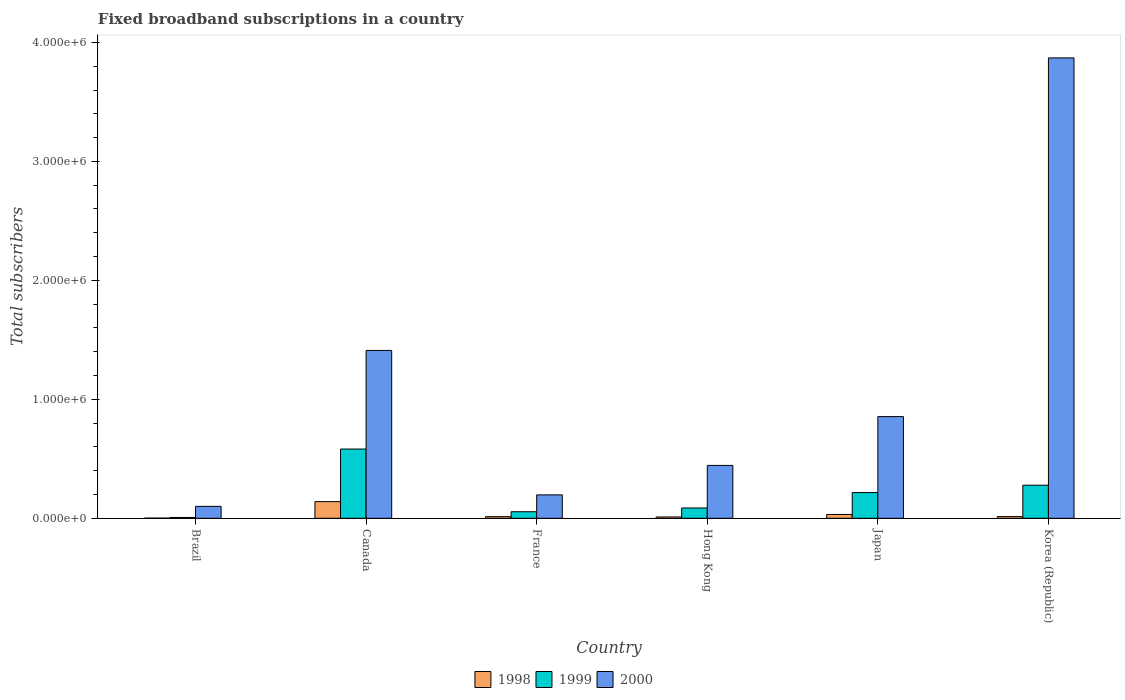How many different coloured bars are there?
Offer a terse response. 3. Are the number of bars on each tick of the X-axis equal?
Offer a very short reply. Yes. How many bars are there on the 4th tick from the right?
Offer a very short reply. 3. In how many cases, is the number of bars for a given country not equal to the number of legend labels?
Provide a succinct answer. 0. What is the number of broadband subscriptions in 2000 in Korea (Republic)?
Provide a succinct answer. 3.87e+06. Across all countries, what is the minimum number of broadband subscriptions in 2000?
Ensure brevity in your answer.  1.00e+05. In which country was the number of broadband subscriptions in 2000 maximum?
Keep it short and to the point. Korea (Republic). In which country was the number of broadband subscriptions in 1998 minimum?
Give a very brief answer. Brazil. What is the total number of broadband subscriptions in 2000 in the graph?
Make the answer very short. 6.88e+06. What is the difference between the number of broadband subscriptions in 2000 in Brazil and that in Hong Kong?
Give a very brief answer. -3.44e+05. What is the difference between the number of broadband subscriptions in 1999 in Brazil and the number of broadband subscriptions in 1998 in Canada?
Provide a short and direct response. -1.33e+05. What is the average number of broadband subscriptions in 2000 per country?
Your response must be concise. 1.15e+06. What is the difference between the number of broadband subscriptions of/in 1998 and number of broadband subscriptions of/in 2000 in Canada?
Your answer should be very brief. -1.27e+06. In how many countries, is the number of broadband subscriptions in 1999 greater than 600000?
Provide a succinct answer. 0. What is the ratio of the number of broadband subscriptions in 1999 in France to that in Hong Kong?
Keep it short and to the point. 0.64. Is the difference between the number of broadband subscriptions in 1998 in Hong Kong and Korea (Republic) greater than the difference between the number of broadband subscriptions in 2000 in Hong Kong and Korea (Republic)?
Ensure brevity in your answer.  Yes. What is the difference between the highest and the second highest number of broadband subscriptions in 2000?
Provide a short and direct response. 2.46e+06. What is the difference between the highest and the lowest number of broadband subscriptions in 1999?
Your answer should be compact. 5.75e+05. Is it the case that in every country, the sum of the number of broadband subscriptions in 2000 and number of broadband subscriptions in 1998 is greater than the number of broadband subscriptions in 1999?
Your response must be concise. Yes. Does the graph contain grids?
Provide a short and direct response. No. How are the legend labels stacked?
Keep it short and to the point. Horizontal. What is the title of the graph?
Offer a terse response. Fixed broadband subscriptions in a country. What is the label or title of the Y-axis?
Make the answer very short. Total subscribers. What is the Total subscribers of 1998 in Brazil?
Give a very brief answer. 1000. What is the Total subscribers in 1999 in Brazil?
Keep it short and to the point. 7000. What is the Total subscribers of 2000 in Brazil?
Your answer should be compact. 1.00e+05. What is the Total subscribers of 1998 in Canada?
Your answer should be very brief. 1.40e+05. What is the Total subscribers of 1999 in Canada?
Make the answer very short. 5.82e+05. What is the Total subscribers of 2000 in Canada?
Keep it short and to the point. 1.41e+06. What is the Total subscribers of 1998 in France?
Ensure brevity in your answer.  1.35e+04. What is the Total subscribers in 1999 in France?
Your answer should be very brief. 5.50e+04. What is the Total subscribers in 2000 in France?
Provide a short and direct response. 1.97e+05. What is the Total subscribers of 1998 in Hong Kong?
Provide a short and direct response. 1.10e+04. What is the Total subscribers of 1999 in Hong Kong?
Provide a succinct answer. 8.65e+04. What is the Total subscribers of 2000 in Hong Kong?
Offer a very short reply. 4.44e+05. What is the Total subscribers of 1998 in Japan?
Make the answer very short. 3.20e+04. What is the Total subscribers of 1999 in Japan?
Your answer should be compact. 2.16e+05. What is the Total subscribers of 2000 in Japan?
Your response must be concise. 8.55e+05. What is the Total subscribers of 1998 in Korea (Republic)?
Offer a terse response. 1.40e+04. What is the Total subscribers of 1999 in Korea (Republic)?
Your response must be concise. 2.78e+05. What is the Total subscribers in 2000 in Korea (Republic)?
Provide a short and direct response. 3.87e+06. Across all countries, what is the maximum Total subscribers in 1999?
Ensure brevity in your answer.  5.82e+05. Across all countries, what is the maximum Total subscribers of 2000?
Your answer should be compact. 3.87e+06. Across all countries, what is the minimum Total subscribers in 1999?
Provide a short and direct response. 7000. What is the total Total subscribers in 1998 in the graph?
Ensure brevity in your answer.  2.11e+05. What is the total Total subscribers of 1999 in the graph?
Your answer should be very brief. 1.22e+06. What is the total Total subscribers of 2000 in the graph?
Your response must be concise. 6.88e+06. What is the difference between the Total subscribers in 1998 in Brazil and that in Canada?
Provide a short and direct response. -1.39e+05. What is the difference between the Total subscribers in 1999 in Brazil and that in Canada?
Provide a short and direct response. -5.75e+05. What is the difference between the Total subscribers of 2000 in Brazil and that in Canada?
Your answer should be compact. -1.31e+06. What is the difference between the Total subscribers of 1998 in Brazil and that in France?
Your answer should be very brief. -1.25e+04. What is the difference between the Total subscribers of 1999 in Brazil and that in France?
Your answer should be compact. -4.80e+04. What is the difference between the Total subscribers of 2000 in Brazil and that in France?
Provide a succinct answer. -9.66e+04. What is the difference between the Total subscribers of 1999 in Brazil and that in Hong Kong?
Your answer should be very brief. -7.95e+04. What is the difference between the Total subscribers of 2000 in Brazil and that in Hong Kong?
Your response must be concise. -3.44e+05. What is the difference between the Total subscribers in 1998 in Brazil and that in Japan?
Give a very brief answer. -3.10e+04. What is the difference between the Total subscribers of 1999 in Brazil and that in Japan?
Offer a very short reply. -2.09e+05. What is the difference between the Total subscribers of 2000 in Brazil and that in Japan?
Keep it short and to the point. -7.55e+05. What is the difference between the Total subscribers in 1998 in Brazil and that in Korea (Republic)?
Provide a succinct answer. -1.30e+04. What is the difference between the Total subscribers of 1999 in Brazil and that in Korea (Republic)?
Offer a very short reply. -2.71e+05. What is the difference between the Total subscribers in 2000 in Brazil and that in Korea (Republic)?
Provide a succinct answer. -3.77e+06. What is the difference between the Total subscribers of 1998 in Canada and that in France?
Provide a short and direct response. 1.27e+05. What is the difference between the Total subscribers in 1999 in Canada and that in France?
Your answer should be very brief. 5.27e+05. What is the difference between the Total subscribers of 2000 in Canada and that in France?
Your answer should be compact. 1.21e+06. What is the difference between the Total subscribers in 1998 in Canada and that in Hong Kong?
Keep it short and to the point. 1.29e+05. What is the difference between the Total subscribers in 1999 in Canada and that in Hong Kong?
Provide a succinct answer. 4.96e+05. What is the difference between the Total subscribers in 2000 in Canada and that in Hong Kong?
Offer a very short reply. 9.66e+05. What is the difference between the Total subscribers of 1998 in Canada and that in Japan?
Keep it short and to the point. 1.08e+05. What is the difference between the Total subscribers of 1999 in Canada and that in Japan?
Provide a short and direct response. 3.66e+05. What is the difference between the Total subscribers in 2000 in Canada and that in Japan?
Make the answer very short. 5.56e+05. What is the difference between the Total subscribers in 1998 in Canada and that in Korea (Republic)?
Your answer should be very brief. 1.26e+05. What is the difference between the Total subscribers of 1999 in Canada and that in Korea (Republic)?
Offer a very short reply. 3.04e+05. What is the difference between the Total subscribers in 2000 in Canada and that in Korea (Republic)?
Your answer should be compact. -2.46e+06. What is the difference between the Total subscribers in 1998 in France and that in Hong Kong?
Offer a very short reply. 2464. What is the difference between the Total subscribers in 1999 in France and that in Hong Kong?
Keep it short and to the point. -3.15e+04. What is the difference between the Total subscribers in 2000 in France and that in Hong Kong?
Provide a succinct answer. -2.48e+05. What is the difference between the Total subscribers of 1998 in France and that in Japan?
Your answer should be very brief. -1.85e+04. What is the difference between the Total subscribers in 1999 in France and that in Japan?
Offer a very short reply. -1.61e+05. What is the difference between the Total subscribers in 2000 in France and that in Japan?
Give a very brief answer. -6.58e+05. What is the difference between the Total subscribers of 1998 in France and that in Korea (Republic)?
Your answer should be very brief. -536. What is the difference between the Total subscribers in 1999 in France and that in Korea (Republic)?
Provide a short and direct response. -2.23e+05. What is the difference between the Total subscribers of 2000 in France and that in Korea (Republic)?
Offer a very short reply. -3.67e+06. What is the difference between the Total subscribers in 1998 in Hong Kong and that in Japan?
Keep it short and to the point. -2.10e+04. What is the difference between the Total subscribers in 1999 in Hong Kong and that in Japan?
Keep it short and to the point. -1.30e+05. What is the difference between the Total subscribers of 2000 in Hong Kong and that in Japan?
Your answer should be compact. -4.10e+05. What is the difference between the Total subscribers of 1998 in Hong Kong and that in Korea (Republic)?
Your response must be concise. -3000. What is the difference between the Total subscribers in 1999 in Hong Kong and that in Korea (Republic)?
Make the answer very short. -1.92e+05. What is the difference between the Total subscribers in 2000 in Hong Kong and that in Korea (Republic)?
Offer a very short reply. -3.43e+06. What is the difference between the Total subscribers in 1998 in Japan and that in Korea (Republic)?
Ensure brevity in your answer.  1.80e+04. What is the difference between the Total subscribers in 1999 in Japan and that in Korea (Republic)?
Offer a terse response. -6.20e+04. What is the difference between the Total subscribers of 2000 in Japan and that in Korea (Republic)?
Your answer should be very brief. -3.02e+06. What is the difference between the Total subscribers of 1998 in Brazil and the Total subscribers of 1999 in Canada?
Make the answer very short. -5.81e+05. What is the difference between the Total subscribers in 1998 in Brazil and the Total subscribers in 2000 in Canada?
Your response must be concise. -1.41e+06. What is the difference between the Total subscribers of 1999 in Brazil and the Total subscribers of 2000 in Canada?
Provide a short and direct response. -1.40e+06. What is the difference between the Total subscribers in 1998 in Brazil and the Total subscribers in 1999 in France?
Make the answer very short. -5.40e+04. What is the difference between the Total subscribers in 1998 in Brazil and the Total subscribers in 2000 in France?
Keep it short and to the point. -1.96e+05. What is the difference between the Total subscribers in 1999 in Brazil and the Total subscribers in 2000 in France?
Keep it short and to the point. -1.90e+05. What is the difference between the Total subscribers of 1998 in Brazil and the Total subscribers of 1999 in Hong Kong?
Ensure brevity in your answer.  -8.55e+04. What is the difference between the Total subscribers of 1998 in Brazil and the Total subscribers of 2000 in Hong Kong?
Make the answer very short. -4.43e+05. What is the difference between the Total subscribers in 1999 in Brazil and the Total subscribers in 2000 in Hong Kong?
Your answer should be compact. -4.37e+05. What is the difference between the Total subscribers in 1998 in Brazil and the Total subscribers in 1999 in Japan?
Give a very brief answer. -2.15e+05. What is the difference between the Total subscribers in 1998 in Brazil and the Total subscribers in 2000 in Japan?
Give a very brief answer. -8.54e+05. What is the difference between the Total subscribers of 1999 in Brazil and the Total subscribers of 2000 in Japan?
Offer a terse response. -8.48e+05. What is the difference between the Total subscribers in 1998 in Brazil and the Total subscribers in 1999 in Korea (Republic)?
Your answer should be very brief. -2.77e+05. What is the difference between the Total subscribers of 1998 in Brazil and the Total subscribers of 2000 in Korea (Republic)?
Your answer should be very brief. -3.87e+06. What is the difference between the Total subscribers in 1999 in Brazil and the Total subscribers in 2000 in Korea (Republic)?
Provide a short and direct response. -3.86e+06. What is the difference between the Total subscribers of 1998 in Canada and the Total subscribers of 1999 in France?
Offer a terse response. 8.50e+04. What is the difference between the Total subscribers in 1998 in Canada and the Total subscribers in 2000 in France?
Your answer should be compact. -5.66e+04. What is the difference between the Total subscribers of 1999 in Canada and the Total subscribers of 2000 in France?
Provide a short and direct response. 3.85e+05. What is the difference between the Total subscribers in 1998 in Canada and the Total subscribers in 1999 in Hong Kong?
Your answer should be compact. 5.35e+04. What is the difference between the Total subscribers in 1998 in Canada and the Total subscribers in 2000 in Hong Kong?
Ensure brevity in your answer.  -3.04e+05. What is the difference between the Total subscribers in 1999 in Canada and the Total subscribers in 2000 in Hong Kong?
Give a very brief answer. 1.38e+05. What is the difference between the Total subscribers of 1998 in Canada and the Total subscribers of 1999 in Japan?
Your answer should be very brief. -7.60e+04. What is the difference between the Total subscribers of 1998 in Canada and the Total subscribers of 2000 in Japan?
Your response must be concise. -7.15e+05. What is the difference between the Total subscribers of 1999 in Canada and the Total subscribers of 2000 in Japan?
Ensure brevity in your answer.  -2.73e+05. What is the difference between the Total subscribers in 1998 in Canada and the Total subscribers in 1999 in Korea (Republic)?
Make the answer very short. -1.38e+05. What is the difference between the Total subscribers of 1998 in Canada and the Total subscribers of 2000 in Korea (Republic)?
Ensure brevity in your answer.  -3.73e+06. What is the difference between the Total subscribers in 1999 in Canada and the Total subscribers in 2000 in Korea (Republic)?
Provide a short and direct response. -3.29e+06. What is the difference between the Total subscribers of 1998 in France and the Total subscribers of 1999 in Hong Kong?
Keep it short and to the point. -7.30e+04. What is the difference between the Total subscribers in 1998 in France and the Total subscribers in 2000 in Hong Kong?
Offer a terse response. -4.31e+05. What is the difference between the Total subscribers of 1999 in France and the Total subscribers of 2000 in Hong Kong?
Your answer should be compact. -3.89e+05. What is the difference between the Total subscribers of 1998 in France and the Total subscribers of 1999 in Japan?
Your response must be concise. -2.03e+05. What is the difference between the Total subscribers of 1998 in France and the Total subscribers of 2000 in Japan?
Your answer should be compact. -8.41e+05. What is the difference between the Total subscribers in 1999 in France and the Total subscribers in 2000 in Japan?
Keep it short and to the point. -8.00e+05. What is the difference between the Total subscribers in 1998 in France and the Total subscribers in 1999 in Korea (Republic)?
Provide a succinct answer. -2.65e+05. What is the difference between the Total subscribers in 1998 in France and the Total subscribers in 2000 in Korea (Republic)?
Give a very brief answer. -3.86e+06. What is the difference between the Total subscribers of 1999 in France and the Total subscribers of 2000 in Korea (Republic)?
Keep it short and to the point. -3.82e+06. What is the difference between the Total subscribers in 1998 in Hong Kong and the Total subscribers in 1999 in Japan?
Provide a short and direct response. -2.05e+05. What is the difference between the Total subscribers in 1998 in Hong Kong and the Total subscribers in 2000 in Japan?
Your response must be concise. -8.44e+05. What is the difference between the Total subscribers in 1999 in Hong Kong and the Total subscribers in 2000 in Japan?
Your answer should be compact. -7.68e+05. What is the difference between the Total subscribers of 1998 in Hong Kong and the Total subscribers of 1999 in Korea (Republic)?
Offer a terse response. -2.67e+05. What is the difference between the Total subscribers in 1998 in Hong Kong and the Total subscribers in 2000 in Korea (Republic)?
Offer a terse response. -3.86e+06. What is the difference between the Total subscribers in 1999 in Hong Kong and the Total subscribers in 2000 in Korea (Republic)?
Offer a very short reply. -3.78e+06. What is the difference between the Total subscribers of 1998 in Japan and the Total subscribers of 1999 in Korea (Republic)?
Your answer should be compact. -2.46e+05. What is the difference between the Total subscribers of 1998 in Japan and the Total subscribers of 2000 in Korea (Republic)?
Offer a very short reply. -3.84e+06. What is the difference between the Total subscribers of 1999 in Japan and the Total subscribers of 2000 in Korea (Republic)?
Make the answer very short. -3.65e+06. What is the average Total subscribers in 1998 per country?
Offer a very short reply. 3.52e+04. What is the average Total subscribers of 1999 per country?
Make the answer very short. 2.04e+05. What is the average Total subscribers of 2000 per country?
Provide a short and direct response. 1.15e+06. What is the difference between the Total subscribers of 1998 and Total subscribers of 1999 in Brazil?
Ensure brevity in your answer.  -6000. What is the difference between the Total subscribers of 1998 and Total subscribers of 2000 in Brazil?
Give a very brief answer. -9.90e+04. What is the difference between the Total subscribers in 1999 and Total subscribers in 2000 in Brazil?
Make the answer very short. -9.30e+04. What is the difference between the Total subscribers of 1998 and Total subscribers of 1999 in Canada?
Your response must be concise. -4.42e+05. What is the difference between the Total subscribers of 1998 and Total subscribers of 2000 in Canada?
Your response must be concise. -1.27e+06. What is the difference between the Total subscribers in 1999 and Total subscribers in 2000 in Canada?
Your answer should be very brief. -8.29e+05. What is the difference between the Total subscribers of 1998 and Total subscribers of 1999 in France?
Ensure brevity in your answer.  -4.15e+04. What is the difference between the Total subscribers in 1998 and Total subscribers in 2000 in France?
Your response must be concise. -1.83e+05. What is the difference between the Total subscribers in 1999 and Total subscribers in 2000 in France?
Give a very brief answer. -1.42e+05. What is the difference between the Total subscribers in 1998 and Total subscribers in 1999 in Hong Kong?
Provide a succinct answer. -7.55e+04. What is the difference between the Total subscribers of 1998 and Total subscribers of 2000 in Hong Kong?
Your answer should be very brief. -4.33e+05. What is the difference between the Total subscribers of 1999 and Total subscribers of 2000 in Hong Kong?
Provide a short and direct response. -3.58e+05. What is the difference between the Total subscribers in 1998 and Total subscribers in 1999 in Japan?
Make the answer very short. -1.84e+05. What is the difference between the Total subscribers of 1998 and Total subscribers of 2000 in Japan?
Offer a very short reply. -8.23e+05. What is the difference between the Total subscribers of 1999 and Total subscribers of 2000 in Japan?
Your answer should be compact. -6.39e+05. What is the difference between the Total subscribers in 1998 and Total subscribers in 1999 in Korea (Republic)?
Offer a terse response. -2.64e+05. What is the difference between the Total subscribers of 1998 and Total subscribers of 2000 in Korea (Republic)?
Offer a very short reply. -3.86e+06. What is the difference between the Total subscribers of 1999 and Total subscribers of 2000 in Korea (Republic)?
Provide a short and direct response. -3.59e+06. What is the ratio of the Total subscribers of 1998 in Brazil to that in Canada?
Your response must be concise. 0.01. What is the ratio of the Total subscribers of 1999 in Brazil to that in Canada?
Give a very brief answer. 0.01. What is the ratio of the Total subscribers in 2000 in Brazil to that in Canada?
Your answer should be very brief. 0.07. What is the ratio of the Total subscribers of 1998 in Brazil to that in France?
Provide a short and direct response. 0.07. What is the ratio of the Total subscribers of 1999 in Brazil to that in France?
Keep it short and to the point. 0.13. What is the ratio of the Total subscribers of 2000 in Brazil to that in France?
Provide a short and direct response. 0.51. What is the ratio of the Total subscribers in 1998 in Brazil to that in Hong Kong?
Offer a terse response. 0.09. What is the ratio of the Total subscribers in 1999 in Brazil to that in Hong Kong?
Make the answer very short. 0.08. What is the ratio of the Total subscribers in 2000 in Brazil to that in Hong Kong?
Give a very brief answer. 0.23. What is the ratio of the Total subscribers in 1998 in Brazil to that in Japan?
Give a very brief answer. 0.03. What is the ratio of the Total subscribers of 1999 in Brazil to that in Japan?
Keep it short and to the point. 0.03. What is the ratio of the Total subscribers in 2000 in Brazil to that in Japan?
Make the answer very short. 0.12. What is the ratio of the Total subscribers of 1998 in Brazil to that in Korea (Republic)?
Make the answer very short. 0.07. What is the ratio of the Total subscribers in 1999 in Brazil to that in Korea (Republic)?
Make the answer very short. 0.03. What is the ratio of the Total subscribers of 2000 in Brazil to that in Korea (Republic)?
Your answer should be compact. 0.03. What is the ratio of the Total subscribers of 1998 in Canada to that in France?
Offer a very short reply. 10.4. What is the ratio of the Total subscribers of 1999 in Canada to that in France?
Ensure brevity in your answer.  10.58. What is the ratio of the Total subscribers in 2000 in Canada to that in France?
Offer a terse response. 7.18. What is the ratio of the Total subscribers in 1998 in Canada to that in Hong Kong?
Provide a succinct answer. 12.73. What is the ratio of the Total subscribers of 1999 in Canada to that in Hong Kong?
Your answer should be compact. 6.73. What is the ratio of the Total subscribers in 2000 in Canada to that in Hong Kong?
Offer a very short reply. 3.17. What is the ratio of the Total subscribers in 1998 in Canada to that in Japan?
Provide a short and direct response. 4.38. What is the ratio of the Total subscribers in 1999 in Canada to that in Japan?
Provide a succinct answer. 2.69. What is the ratio of the Total subscribers of 2000 in Canada to that in Japan?
Your response must be concise. 1.65. What is the ratio of the Total subscribers of 1999 in Canada to that in Korea (Republic)?
Ensure brevity in your answer.  2.09. What is the ratio of the Total subscribers of 2000 in Canada to that in Korea (Republic)?
Ensure brevity in your answer.  0.36. What is the ratio of the Total subscribers of 1998 in France to that in Hong Kong?
Your answer should be compact. 1.22. What is the ratio of the Total subscribers of 1999 in France to that in Hong Kong?
Make the answer very short. 0.64. What is the ratio of the Total subscribers in 2000 in France to that in Hong Kong?
Your answer should be very brief. 0.44. What is the ratio of the Total subscribers of 1998 in France to that in Japan?
Ensure brevity in your answer.  0.42. What is the ratio of the Total subscribers in 1999 in France to that in Japan?
Keep it short and to the point. 0.25. What is the ratio of the Total subscribers of 2000 in France to that in Japan?
Give a very brief answer. 0.23. What is the ratio of the Total subscribers of 1998 in France to that in Korea (Republic)?
Your answer should be compact. 0.96. What is the ratio of the Total subscribers of 1999 in France to that in Korea (Republic)?
Ensure brevity in your answer.  0.2. What is the ratio of the Total subscribers in 2000 in France to that in Korea (Republic)?
Offer a terse response. 0.05. What is the ratio of the Total subscribers in 1998 in Hong Kong to that in Japan?
Make the answer very short. 0.34. What is the ratio of the Total subscribers of 1999 in Hong Kong to that in Japan?
Offer a terse response. 0.4. What is the ratio of the Total subscribers of 2000 in Hong Kong to that in Japan?
Provide a short and direct response. 0.52. What is the ratio of the Total subscribers in 1998 in Hong Kong to that in Korea (Republic)?
Offer a terse response. 0.79. What is the ratio of the Total subscribers of 1999 in Hong Kong to that in Korea (Republic)?
Your response must be concise. 0.31. What is the ratio of the Total subscribers of 2000 in Hong Kong to that in Korea (Republic)?
Offer a terse response. 0.11. What is the ratio of the Total subscribers of 1998 in Japan to that in Korea (Republic)?
Provide a short and direct response. 2.29. What is the ratio of the Total subscribers of 1999 in Japan to that in Korea (Republic)?
Provide a succinct answer. 0.78. What is the ratio of the Total subscribers in 2000 in Japan to that in Korea (Republic)?
Your response must be concise. 0.22. What is the difference between the highest and the second highest Total subscribers in 1998?
Your response must be concise. 1.08e+05. What is the difference between the highest and the second highest Total subscribers of 1999?
Offer a terse response. 3.04e+05. What is the difference between the highest and the second highest Total subscribers in 2000?
Offer a very short reply. 2.46e+06. What is the difference between the highest and the lowest Total subscribers of 1998?
Offer a terse response. 1.39e+05. What is the difference between the highest and the lowest Total subscribers of 1999?
Provide a succinct answer. 5.75e+05. What is the difference between the highest and the lowest Total subscribers of 2000?
Make the answer very short. 3.77e+06. 